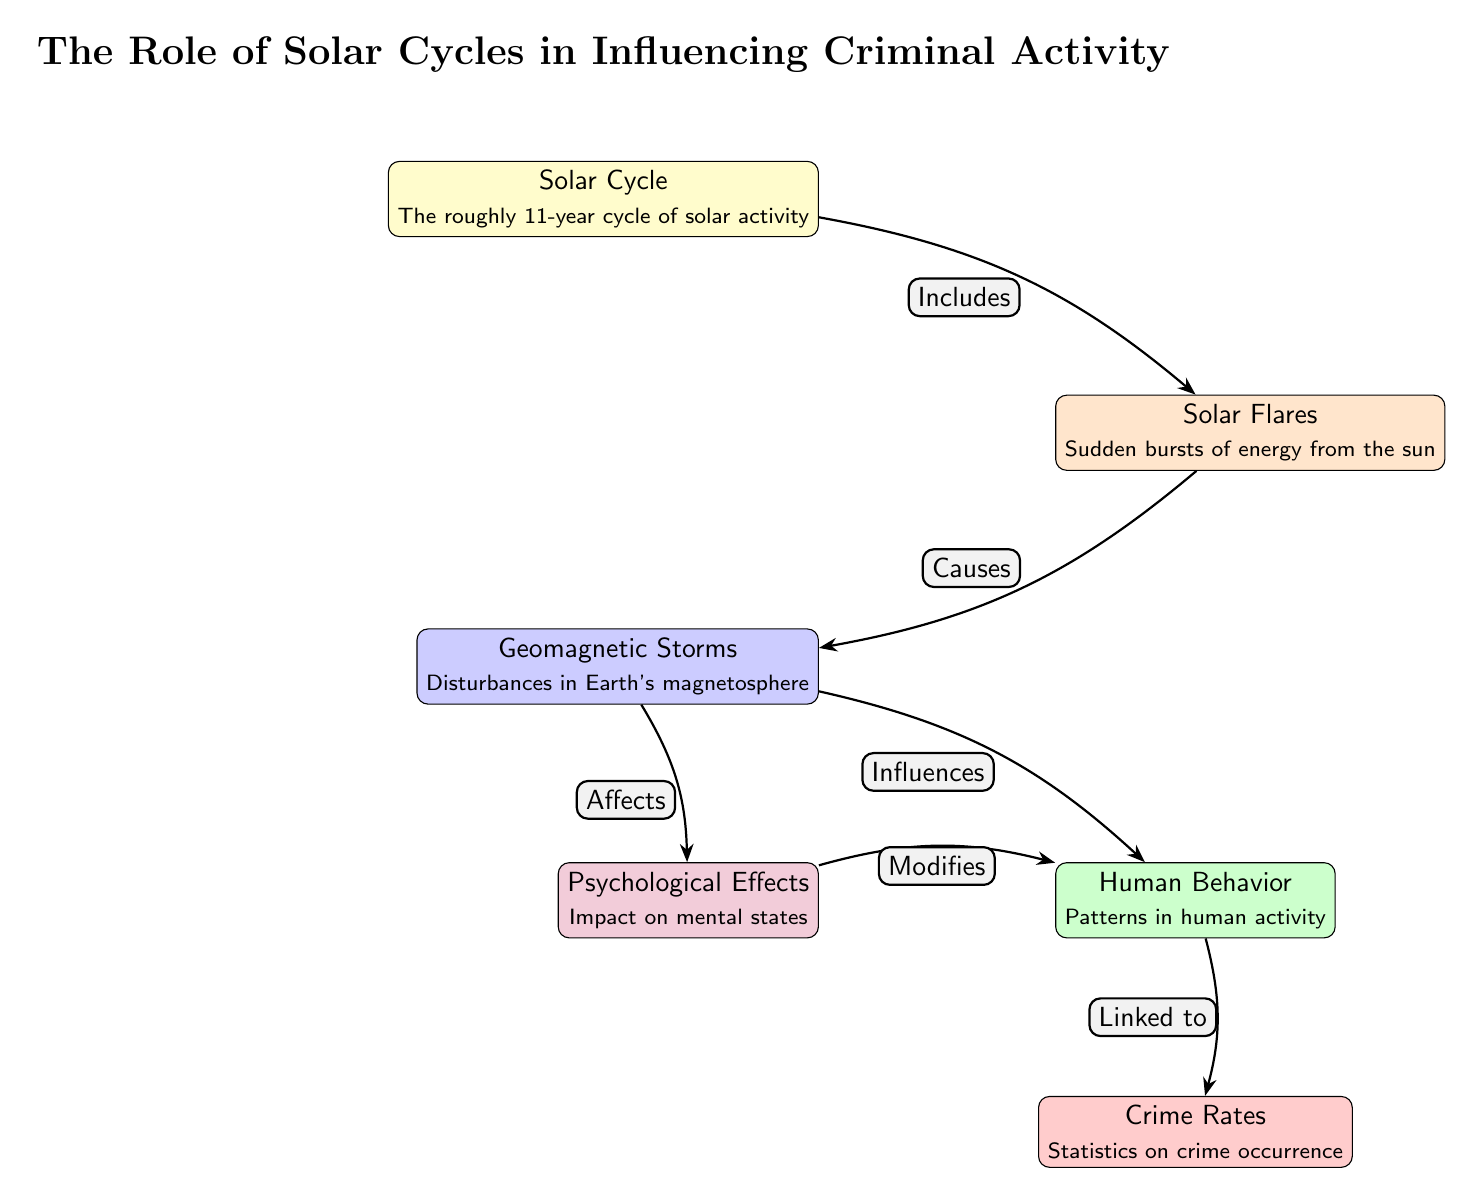What is the main topic of the diagram? The diagram focuses on the role of solar cycles in influencing criminal activity, as stated in the title at the top of the diagram.
Answer: The Role of Solar Cycles in Influencing Criminal Activity How many nodes are present in the diagram? Counting the individual nodes in the diagram, there are a total of six distinct nodes: Solar Cycle, Solar Flares, Geomagnetic Storms, Human Behavior, Crime Rates, and Psychological Effects.
Answer: 6 What effect do solar flares have on geomagnetic storms? According to the diagram, solar flares cause geomagnetic storms, indicated by the directed edge from the node "Solar Flares" to the node "Geomagnetic Storms" labeled "Causes."
Answer: Causes What influences human behavior according to the diagram? The diagram shows that geomagnetic storms influence human behavior. This is depicted with the edge from "Geomagnetic Storms" to "Human Behavior" labeled "Influences."
Answer: Geomagnetic Storms Which psychological aspect is linked to human behavior? The diagram indicates that psychological effects modify human behavior, as shown by the directed edge from "Psychological Effects" to "Human Behavior" labeled "Modifies."
Answer: Modifies What effect do geomagnetic storms have on psychological effects? The diagram illustrates that geomagnetic storms affect psychological effects, indicated by the directed edge from "Geomagnetic Storms" to "Psychological Effects" labeled "Affects."
Answer: Affects How do crime rates relate to human behavior? The crime rates are linked to human behavior as shown in the diagram, where the edge connecting "Human Behavior" and "Crime Rates" is labeled "Linked to."
Answer: Linked to What type of activity is represented by solar cycles? Solar cycles represent a roughly 11-year cycle of solar activity, mentioned in the description of the "Solar Cycle" node.
Answer: 11-year cycle of solar activity Which node is directly affected by psychological effects? The node that is directly modified by psychological effects is "Human Behavior," as shown by the edge from "Psychological Effects" directed to "Human Behavior" labeled "Modifies."
Answer: Human Behavior 